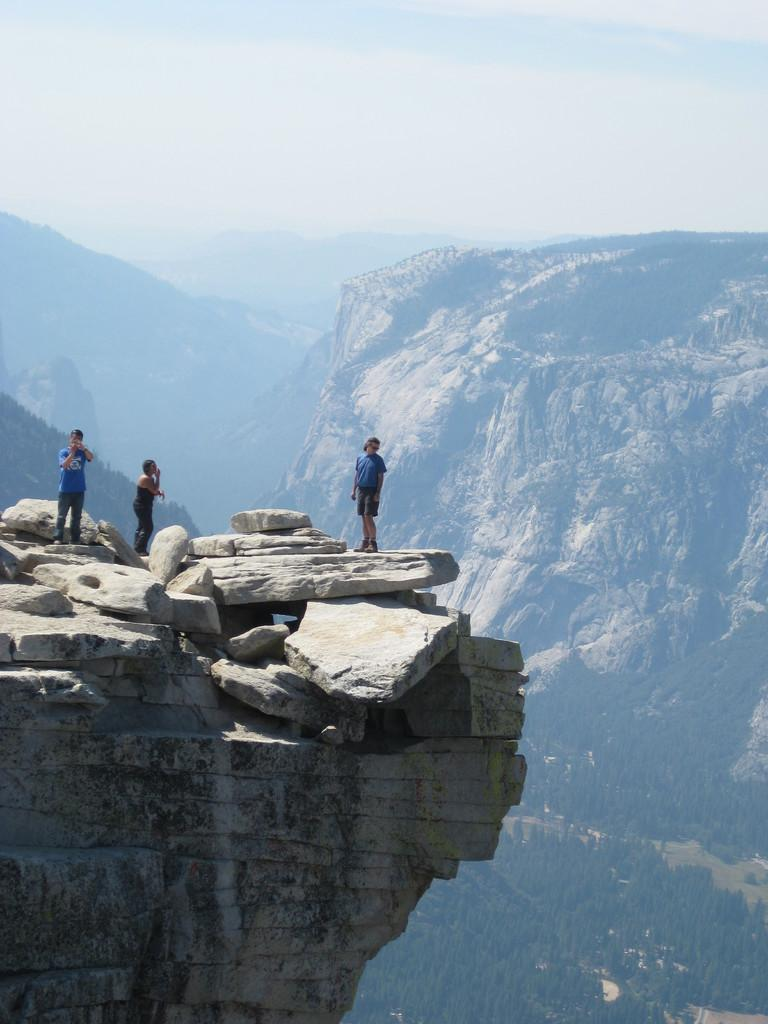How many people are standing on the rocks in the image? There are three persons standing on the rocks in the image. What can be seen in the background of the image? Hills and the sky are visible in the background of the image. Where are the trees located in the image? The trees are in the bottom right corner of the image. What type of apparatus is being used by the beggar in the image? There is no beggar or apparatus present in the image. What color is the orange that the person is holding in the image? There is no orange present in the image. 